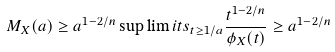Convert formula to latex. <formula><loc_0><loc_0><loc_500><loc_500>M _ { X } ( a ) \geq a ^ { 1 - 2 / n } \sup \lim i t s _ { t \geq 1 / a } \frac { t ^ { 1 - 2 / n } } { \phi _ { X } ( t ) } \geq a ^ { 1 - 2 / n }</formula> 